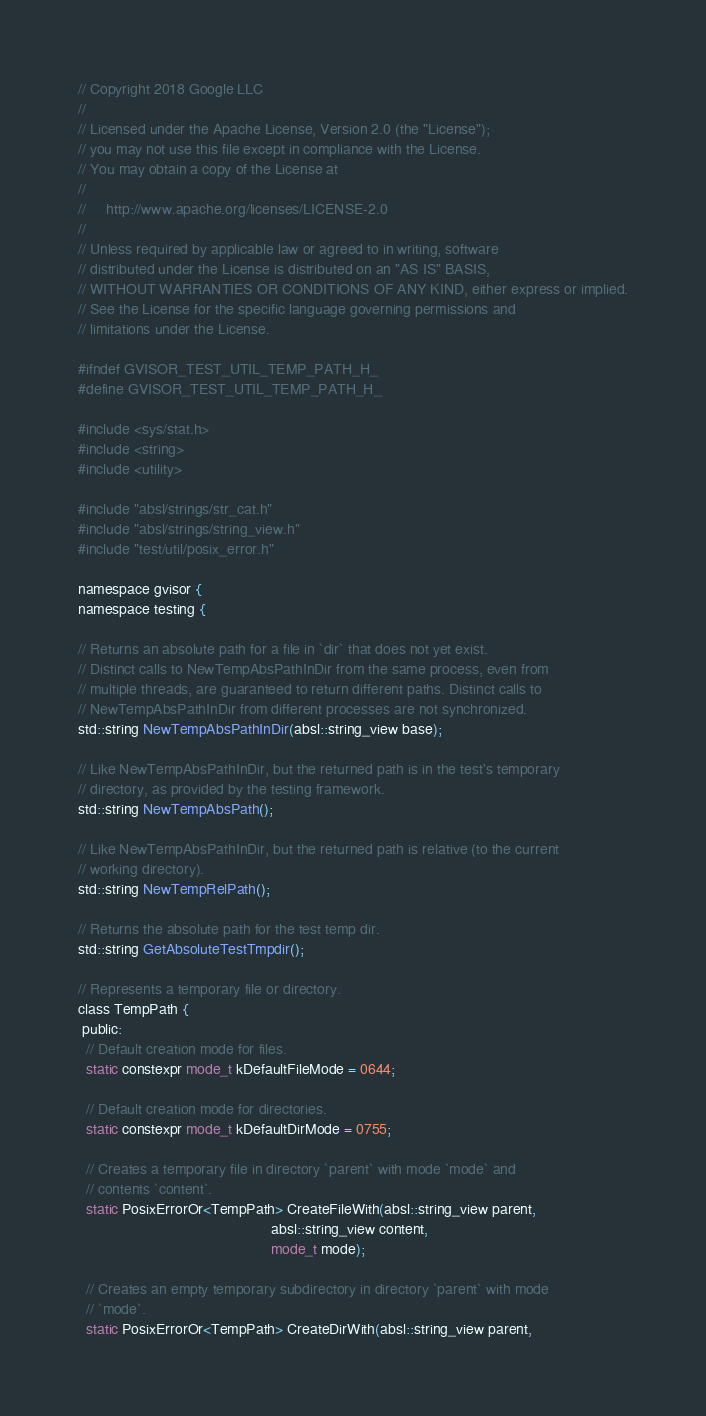Convert code to text. <code><loc_0><loc_0><loc_500><loc_500><_C_>// Copyright 2018 Google LLC
//
// Licensed under the Apache License, Version 2.0 (the "License");
// you may not use this file except in compliance with the License.
// You may obtain a copy of the License at
//
//     http://www.apache.org/licenses/LICENSE-2.0
//
// Unless required by applicable law or agreed to in writing, software
// distributed under the License is distributed on an "AS IS" BASIS,
// WITHOUT WARRANTIES OR CONDITIONS OF ANY KIND, either express or implied.
// See the License for the specific language governing permissions and
// limitations under the License.

#ifndef GVISOR_TEST_UTIL_TEMP_PATH_H_
#define GVISOR_TEST_UTIL_TEMP_PATH_H_

#include <sys/stat.h>
#include <string>
#include <utility>

#include "absl/strings/str_cat.h"
#include "absl/strings/string_view.h"
#include "test/util/posix_error.h"

namespace gvisor {
namespace testing {

// Returns an absolute path for a file in `dir` that does not yet exist.
// Distinct calls to NewTempAbsPathInDir from the same process, even from
// multiple threads, are guaranteed to return different paths. Distinct calls to
// NewTempAbsPathInDir from different processes are not synchronized.
std::string NewTempAbsPathInDir(absl::string_view base);

// Like NewTempAbsPathInDir, but the returned path is in the test's temporary
// directory, as provided by the testing framework.
std::string NewTempAbsPath();

// Like NewTempAbsPathInDir, but the returned path is relative (to the current
// working directory).
std::string NewTempRelPath();

// Returns the absolute path for the test temp dir.
std::string GetAbsoluteTestTmpdir();

// Represents a temporary file or directory.
class TempPath {
 public:
  // Default creation mode for files.
  static constexpr mode_t kDefaultFileMode = 0644;

  // Default creation mode for directories.
  static constexpr mode_t kDefaultDirMode = 0755;

  // Creates a temporary file in directory `parent` with mode `mode` and
  // contents `content`.
  static PosixErrorOr<TempPath> CreateFileWith(absl::string_view parent,
                                               absl::string_view content,
                                               mode_t mode);

  // Creates an empty temporary subdirectory in directory `parent` with mode
  // `mode`.
  static PosixErrorOr<TempPath> CreateDirWith(absl::string_view parent,</code> 